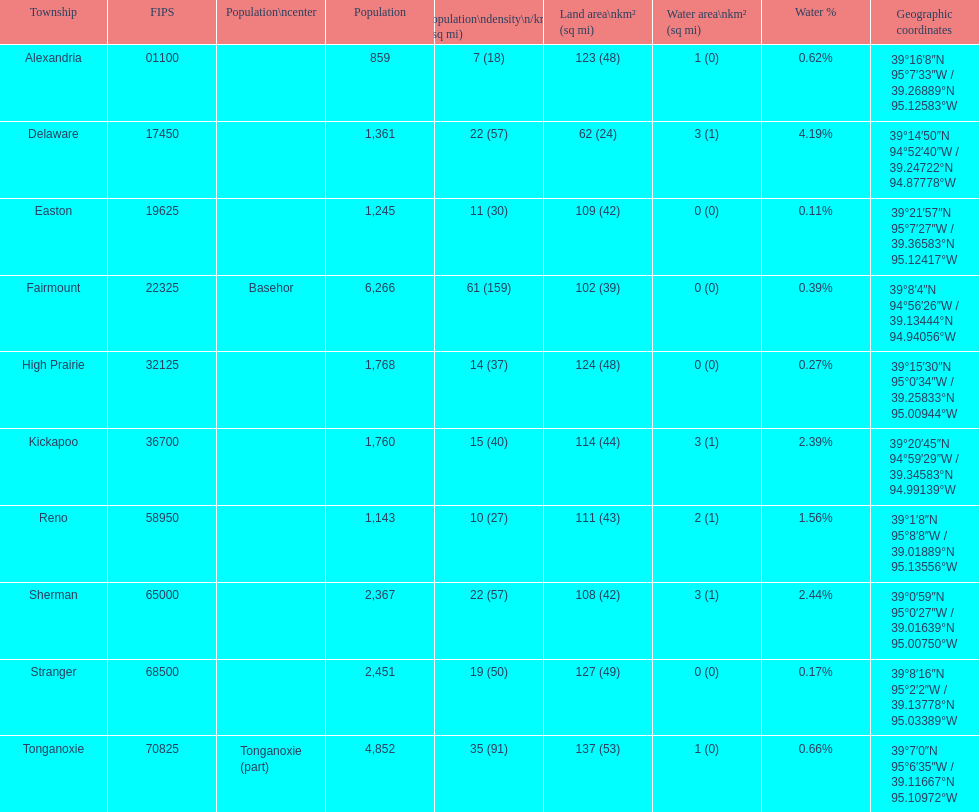What is the difference in populace size for easton and reno? 102. 